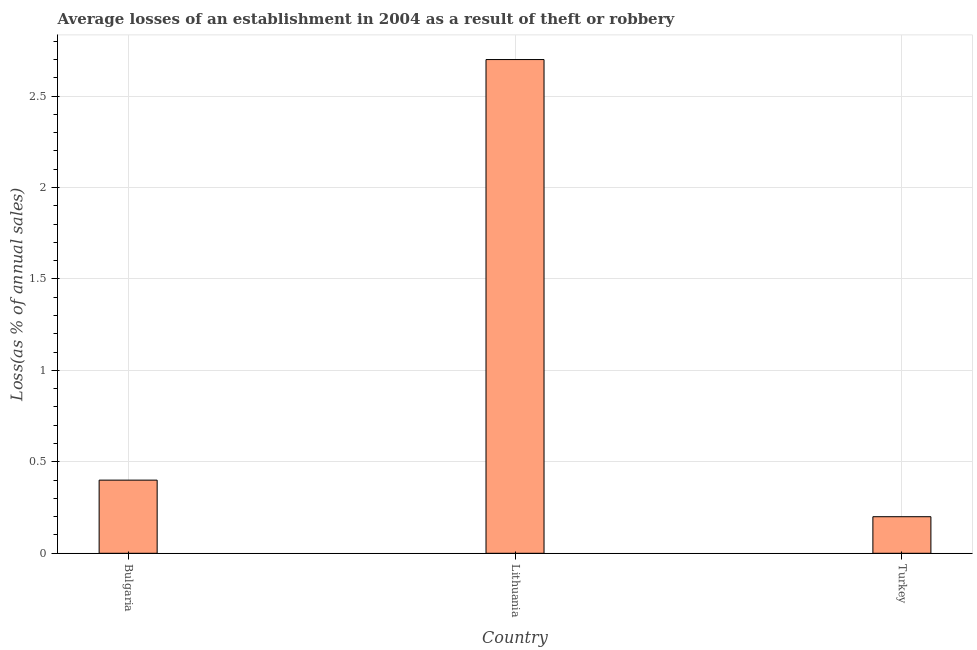Does the graph contain grids?
Your response must be concise. Yes. What is the title of the graph?
Give a very brief answer. Average losses of an establishment in 2004 as a result of theft or robbery. What is the label or title of the Y-axis?
Offer a very short reply. Loss(as % of annual sales). What is the losses due to theft in Turkey?
Ensure brevity in your answer.  0.2. Across all countries, what is the maximum losses due to theft?
Offer a very short reply. 2.7. In which country was the losses due to theft maximum?
Provide a succinct answer. Lithuania. In which country was the losses due to theft minimum?
Give a very brief answer. Turkey. What is the sum of the losses due to theft?
Make the answer very short. 3.3. What is the difference between the losses due to theft in Bulgaria and Turkey?
Your answer should be very brief. 0.2. What is the average losses due to theft per country?
Provide a short and direct response. 1.1. Is the difference between the losses due to theft in Bulgaria and Turkey greater than the difference between any two countries?
Your answer should be compact. No. Is the sum of the losses due to theft in Bulgaria and Turkey greater than the maximum losses due to theft across all countries?
Offer a very short reply. No. How many countries are there in the graph?
Keep it short and to the point. 3. What is the Loss(as % of annual sales) of Bulgaria?
Your answer should be very brief. 0.4. What is the Loss(as % of annual sales) in Lithuania?
Your answer should be very brief. 2.7. What is the Loss(as % of annual sales) of Turkey?
Offer a very short reply. 0.2. What is the difference between the Loss(as % of annual sales) in Bulgaria and Turkey?
Provide a short and direct response. 0.2. What is the ratio of the Loss(as % of annual sales) in Bulgaria to that in Lithuania?
Give a very brief answer. 0.15. What is the ratio of the Loss(as % of annual sales) in Bulgaria to that in Turkey?
Your answer should be very brief. 2. What is the ratio of the Loss(as % of annual sales) in Lithuania to that in Turkey?
Your response must be concise. 13.5. 